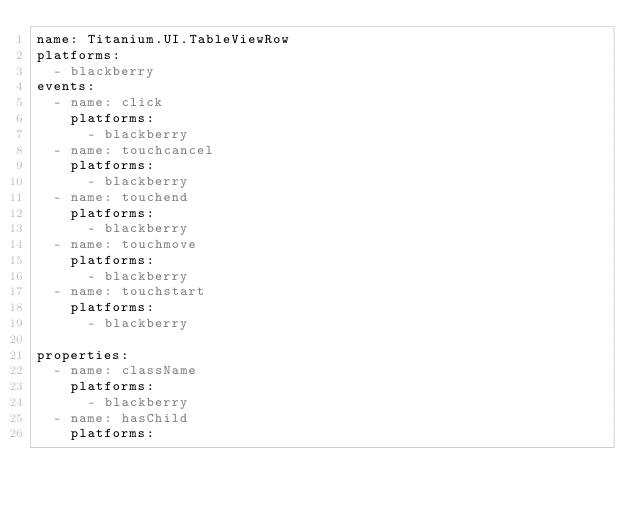Convert code to text. <code><loc_0><loc_0><loc_500><loc_500><_YAML_>name: Titanium.UI.TableViewRow
platforms:
  - blackberry
events:
  - name: click
    platforms:
      - blackberry
  - name: touchcancel
    platforms:
      - blackberry
  - name: touchend
    platforms:
      - blackberry
  - name: touchmove
    platforms:
      - blackberry
  - name: touchstart
    platforms:
      - blackberry

properties:
  - name: className
    platforms:
      - blackberry
  - name: hasChild
    platforms:</code> 